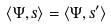Convert formula to latex. <formula><loc_0><loc_0><loc_500><loc_500>\langle \Psi , s \rangle = \langle \Psi , s ^ { \prime } \rangle</formula> 